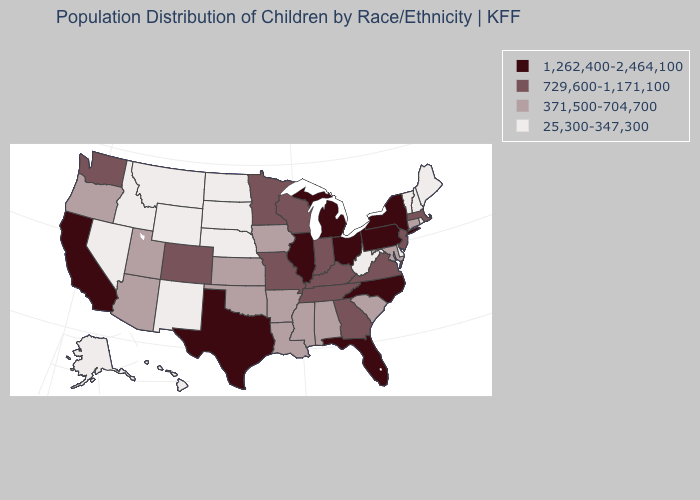Name the states that have a value in the range 25,300-347,300?
Be succinct. Alaska, Delaware, Hawaii, Idaho, Maine, Montana, Nebraska, Nevada, New Hampshire, New Mexico, North Dakota, Rhode Island, South Dakota, Vermont, West Virginia, Wyoming. Which states have the highest value in the USA?
Short answer required. California, Florida, Illinois, Michigan, New York, North Carolina, Ohio, Pennsylvania, Texas. What is the value of Indiana?
Short answer required. 729,600-1,171,100. What is the value of Iowa?
Be succinct. 371,500-704,700. What is the highest value in states that border Mississippi?
Give a very brief answer. 729,600-1,171,100. Does California have the same value as North Carolina?
Keep it brief. Yes. What is the lowest value in the USA?
Answer briefly. 25,300-347,300. Does the map have missing data?
Be succinct. No. What is the lowest value in states that border Kansas?
Keep it brief. 25,300-347,300. Name the states that have a value in the range 25,300-347,300?
Keep it brief. Alaska, Delaware, Hawaii, Idaho, Maine, Montana, Nebraska, Nevada, New Hampshire, New Mexico, North Dakota, Rhode Island, South Dakota, Vermont, West Virginia, Wyoming. What is the lowest value in the USA?
Keep it brief. 25,300-347,300. Name the states that have a value in the range 1,262,400-2,464,100?
Quick response, please. California, Florida, Illinois, Michigan, New York, North Carolina, Ohio, Pennsylvania, Texas. What is the value of Delaware?
Give a very brief answer. 25,300-347,300. Name the states that have a value in the range 729,600-1,171,100?
Keep it brief. Colorado, Georgia, Indiana, Kentucky, Massachusetts, Minnesota, Missouri, New Jersey, Tennessee, Virginia, Washington, Wisconsin. Name the states that have a value in the range 25,300-347,300?
Concise answer only. Alaska, Delaware, Hawaii, Idaho, Maine, Montana, Nebraska, Nevada, New Hampshire, New Mexico, North Dakota, Rhode Island, South Dakota, Vermont, West Virginia, Wyoming. 